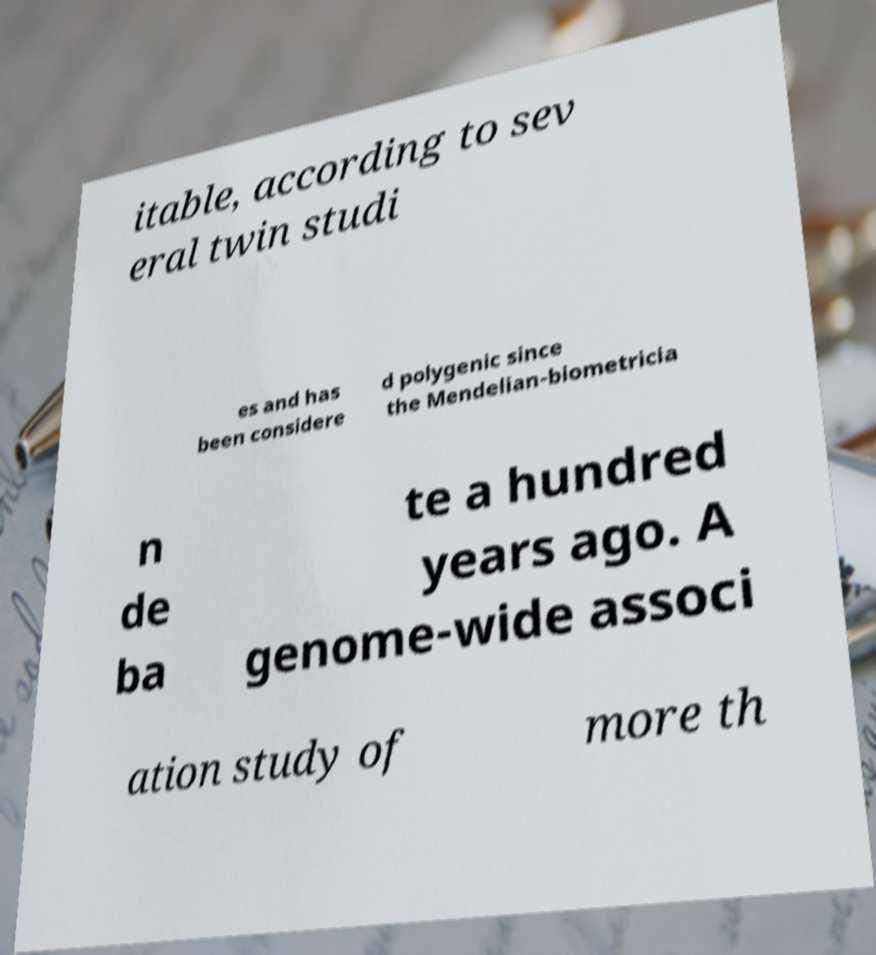What messages or text are displayed in this image? I need them in a readable, typed format. itable, according to sev eral twin studi es and has been considere d polygenic since the Mendelian-biometricia n de ba te a hundred years ago. A genome-wide associ ation study of more th 